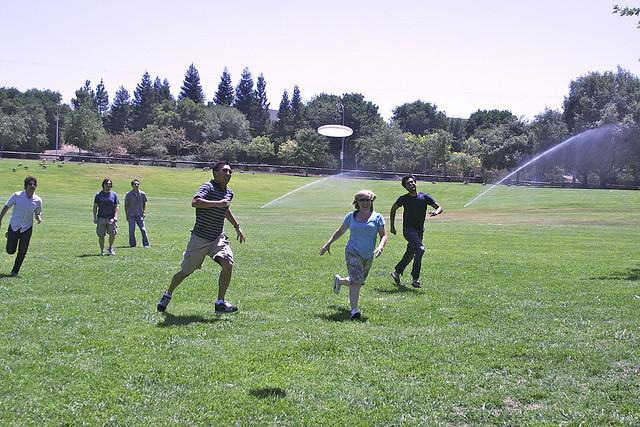Is anyone carrying a purse?
Be succinct. No. Is there water in the picture?
Answer briefly. Yes. How many adults are standing?
Answer briefly. 6. How many people are in the picture?
Write a very short answer. 6. What sport is being played?
Short answer required. Frisbee. 